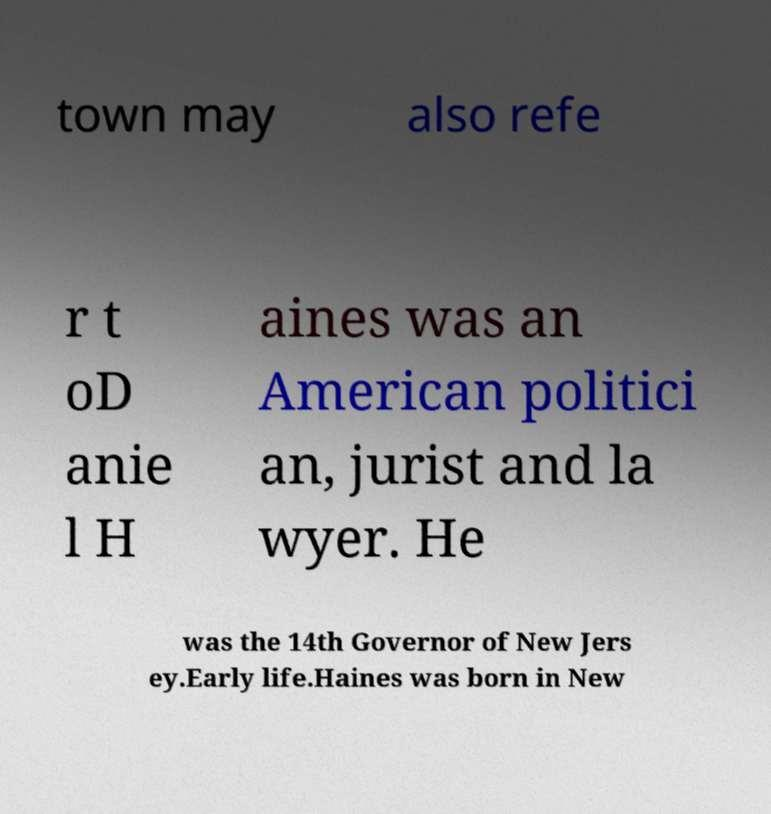Can you read and provide the text displayed in the image?This photo seems to have some interesting text. Can you extract and type it out for me? town may also refe r t oD anie l H aines was an American politici an, jurist and la wyer. He was the 14th Governor of New Jers ey.Early life.Haines was born in New 